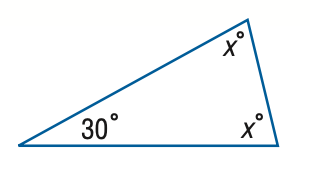Answer the mathemtical geometry problem and directly provide the correct option letter.
Question: Find x.
Choices: A: 60 B: 65 C: 70 D: 75 D 